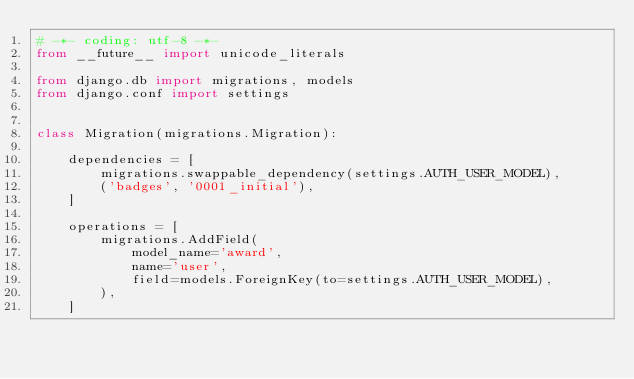Convert code to text. <code><loc_0><loc_0><loc_500><loc_500><_Python_># -*- coding: utf-8 -*-
from __future__ import unicode_literals

from django.db import migrations, models
from django.conf import settings


class Migration(migrations.Migration):

    dependencies = [
        migrations.swappable_dependency(settings.AUTH_USER_MODEL),
        ('badges', '0001_initial'),
    ]

    operations = [
        migrations.AddField(
            model_name='award',
            name='user',
            field=models.ForeignKey(to=settings.AUTH_USER_MODEL),
        ),
    ]
</code> 